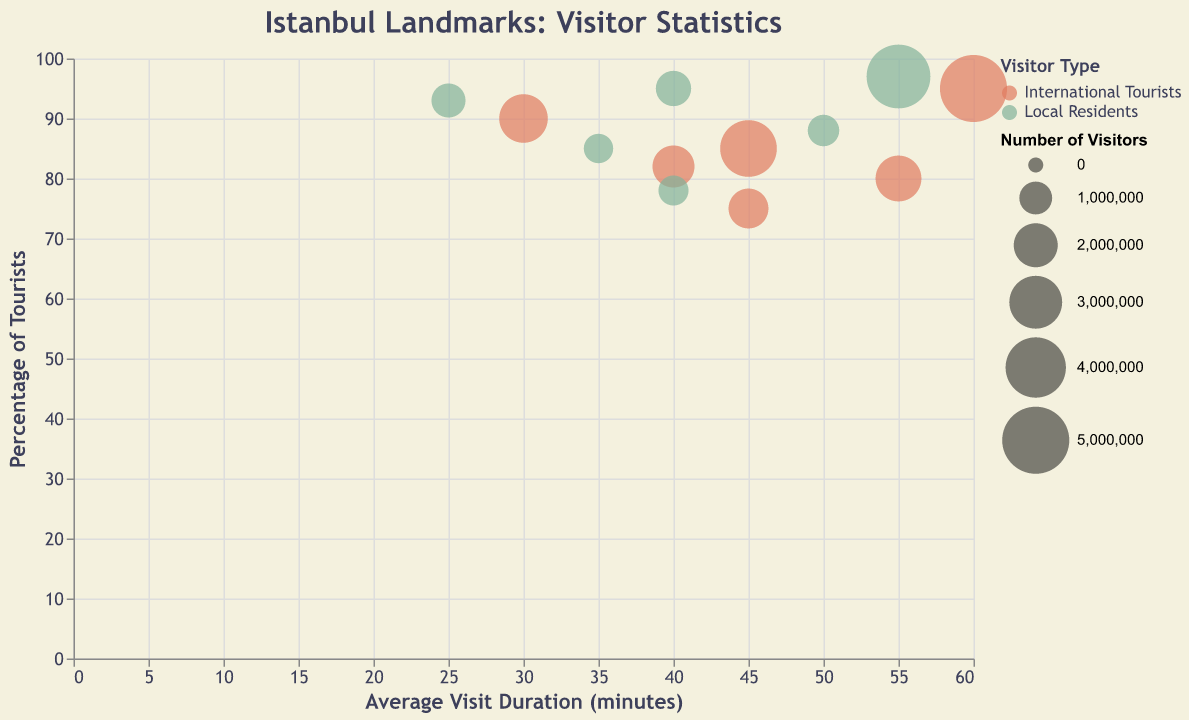What is the title of the chart? The title of the chart is typically placed at the top of the figure. In this case, it is explicitly specified in the code provided.
Answer: Istanbul Landmarks: Visitor Statistics How many different landmarks are represented in the chart? Each landmark is mentioned in the data. To find the number of different landmarks, count the unique landmark names. The landmarks listed are Hagia Sophia, Topkapi Palace, Blue Mosque, Basilica Cistern, Grand Bazaar, and Galata Tower.
Answer: 6 Which landmark has the highest number of total visitors? The visitor counts for each landmark, considering both international tourists and local residents, need to be identified and summed. The Grand Bazaar has 5,000,000 international tourists and 4,500,000 local residents, totaling 9,500,000 visitors, which is the highest.
Answer: Grand Bazaar What is the smallest average visit duration across all landmarks? Compare the 'Average_Visit_Duration' values for all entries. The shortest duration is 25 minutes at Blue Mosque for local residents.
Answer: 25 minutes Which demographic group visits Topkapi Palace for a longer average duration? Refer to the 'Average_Visit_Duration' for Topkapi Palace under both demographic groups. International tourists have an average visit duration of 55 minutes, while local residents have 50 minutes.
Answer: International tourists Which landmark has the highest ratio of international tourists to local residents in terms of visitor count? Calculate the ratio for each landmark by dividing the international visitor count by the local visitor count. The Blue Mosque has international tourists count of 2,500,000 and local residents count of 1,100,000, making approximately a 2.27:1 ratio, which is the highest.
Answer: Blue Mosque How many total visitors does Hagia Sophia get? Sum the visitors from both demographic groups for Hagia Sophia. It has 3,500,000 international tourists and 1,200,000 local residents, totaling 4,700,000 visitors.
Answer: 4,700,000 Which landmark has the smallest difference in average visit duration between international tourists and local residents? Calculate the difference in average visit duration for each landmark.
1. Hagia Sophia: 45 - 40 = 5
2. Topkapi Palace: 55 - 50 = 5
3. Blue Mosque: 30 - 25 = 5
4. Basilica Cistern: 40 - 35 = 5
5. Grand Bazaar: 60 - 55 = 5
6. Galata Tower: 45 - 40 = 5
All landmarks have the same difference of 5 minutes.
Answer: All landmarks Which landmark has the smallest visitor count for international tourists? Compare the 'Visitor_Count' for international tourists across all landmarks. The lowest count is for Galata Tower with 1,600,000 visitors.
Answer: Galata Tower 